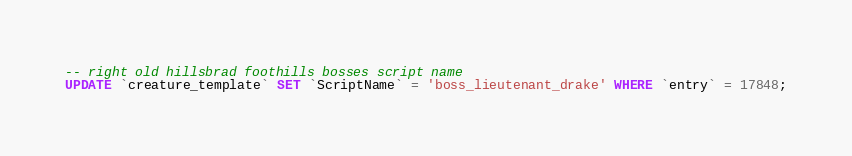Convert code to text. <code><loc_0><loc_0><loc_500><loc_500><_SQL_>
-- right old hillsbrad foothills bosses script name
UPDATE `creature_template` SET `ScriptName` = 'boss_lieutenant_drake' WHERE `entry` = 17848;</code> 